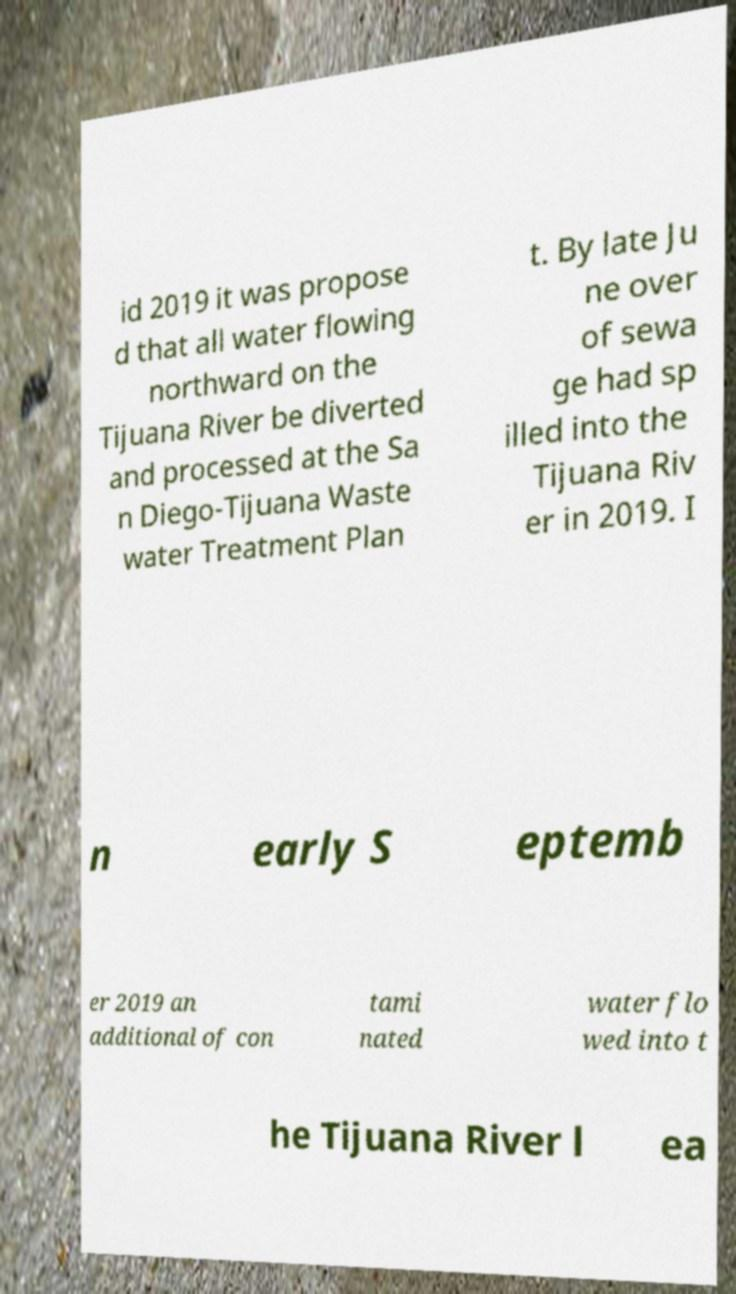There's text embedded in this image that I need extracted. Can you transcribe it verbatim? id 2019 it was propose d that all water flowing northward on the Tijuana River be diverted and processed at the Sa n Diego-Tijuana Waste water Treatment Plan t. By late Ju ne over of sewa ge had sp illed into the Tijuana Riv er in 2019. I n early S eptemb er 2019 an additional of con tami nated water flo wed into t he Tijuana River l ea 